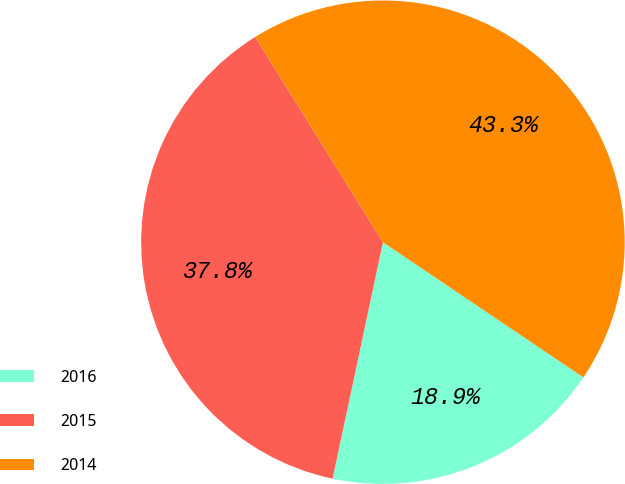<chart> <loc_0><loc_0><loc_500><loc_500><pie_chart><fcel>2016<fcel>2015<fcel>2014<nl><fcel>18.9%<fcel>37.8%<fcel>43.31%<nl></chart> 